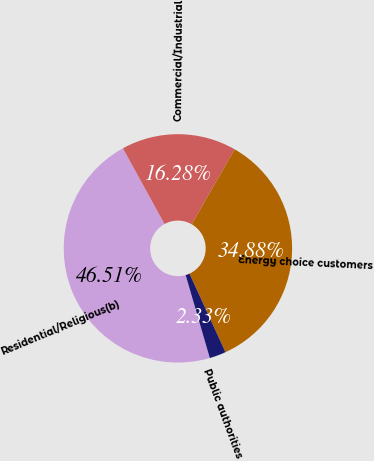Convert chart. <chart><loc_0><loc_0><loc_500><loc_500><pie_chart><fcel>Residential/Religious(b)<fcel>Commercial/Industrial<fcel>Energy choice customers<fcel>Public authorities<nl><fcel>46.51%<fcel>16.28%<fcel>34.88%<fcel>2.33%<nl></chart> 